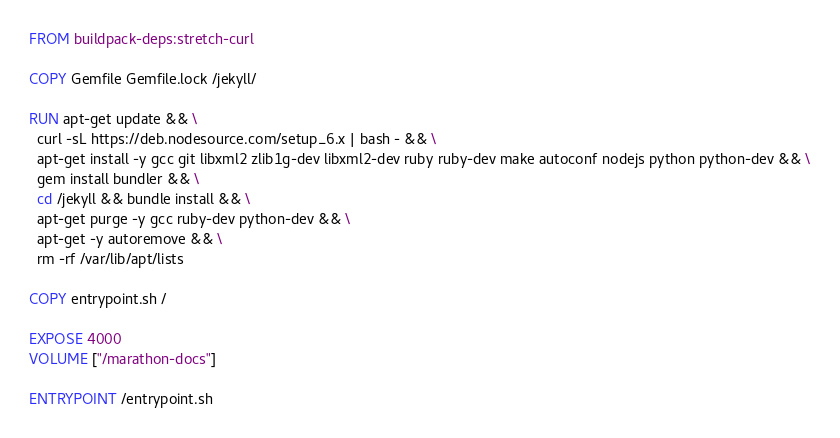<code> <loc_0><loc_0><loc_500><loc_500><_Dockerfile_>FROM buildpack-deps:stretch-curl

COPY Gemfile Gemfile.lock /jekyll/

RUN apt-get update && \
  curl -sL https://deb.nodesource.com/setup_6.x | bash - && \
  apt-get install -y gcc git libxml2 zlib1g-dev libxml2-dev ruby ruby-dev make autoconf nodejs python python-dev && \
  gem install bundler && \
  cd /jekyll && bundle install && \
  apt-get purge -y gcc ruby-dev python-dev && \
  apt-get -y autoremove && \
  rm -rf /var/lib/apt/lists

COPY entrypoint.sh /

EXPOSE 4000
VOLUME ["/marathon-docs"]

ENTRYPOINT /entrypoint.sh
</code> 